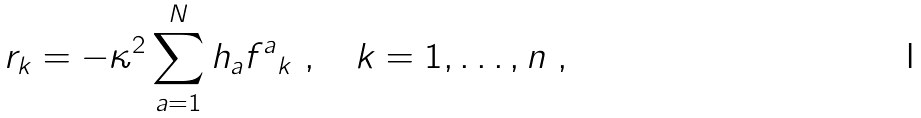Convert formula to latex. <formula><loc_0><loc_0><loc_500><loc_500>r _ { k } = - \kappa ^ { 2 } \sum _ { a = 1 } ^ { N } h _ { a } { f ^ { a } } _ { k } \ , \quad k = 1 , \dots , n \ ,</formula> 